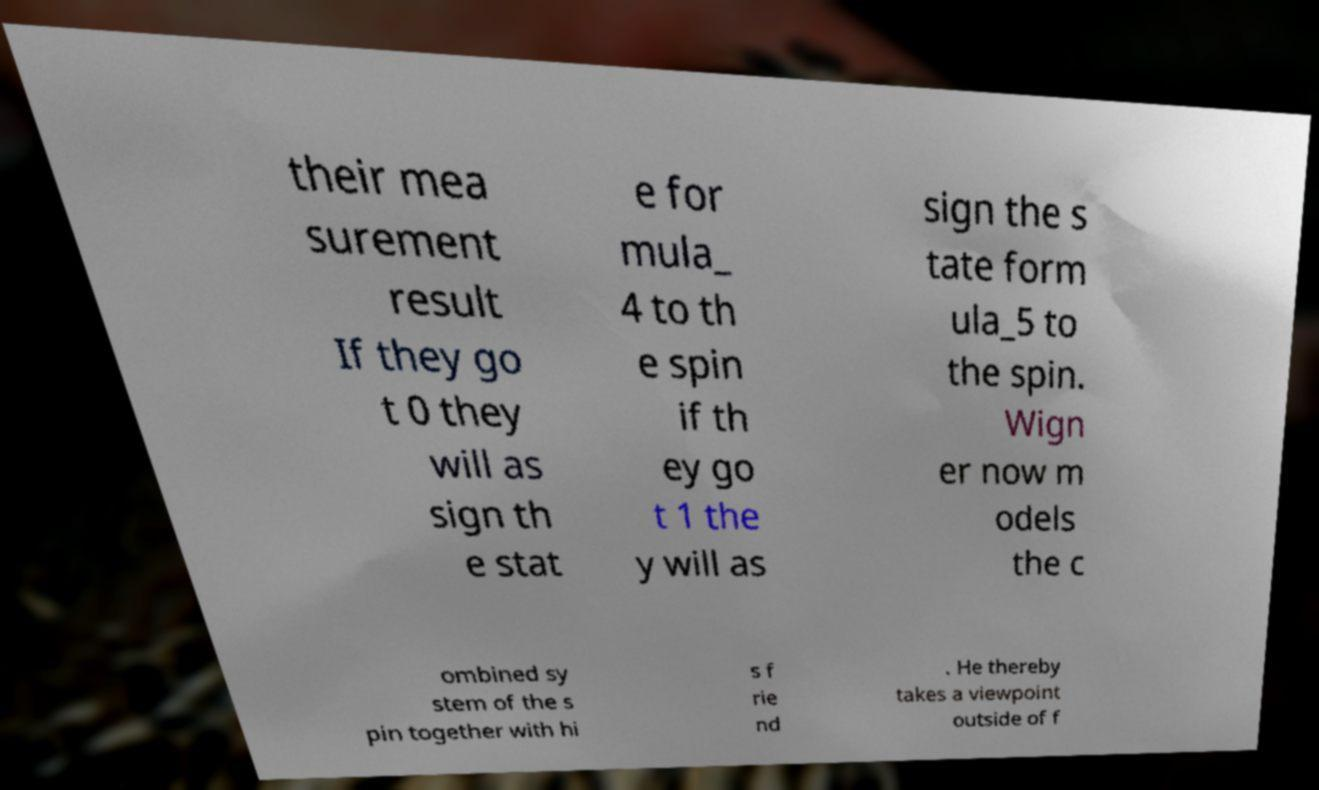Can you accurately transcribe the text from the provided image for me? their mea surement result If they go t 0 they will as sign th e stat e for mula_ 4 to th e spin if th ey go t 1 the y will as sign the s tate form ula_5 to the spin. Wign er now m odels the c ombined sy stem of the s pin together with hi s f rie nd . He thereby takes a viewpoint outside of f 